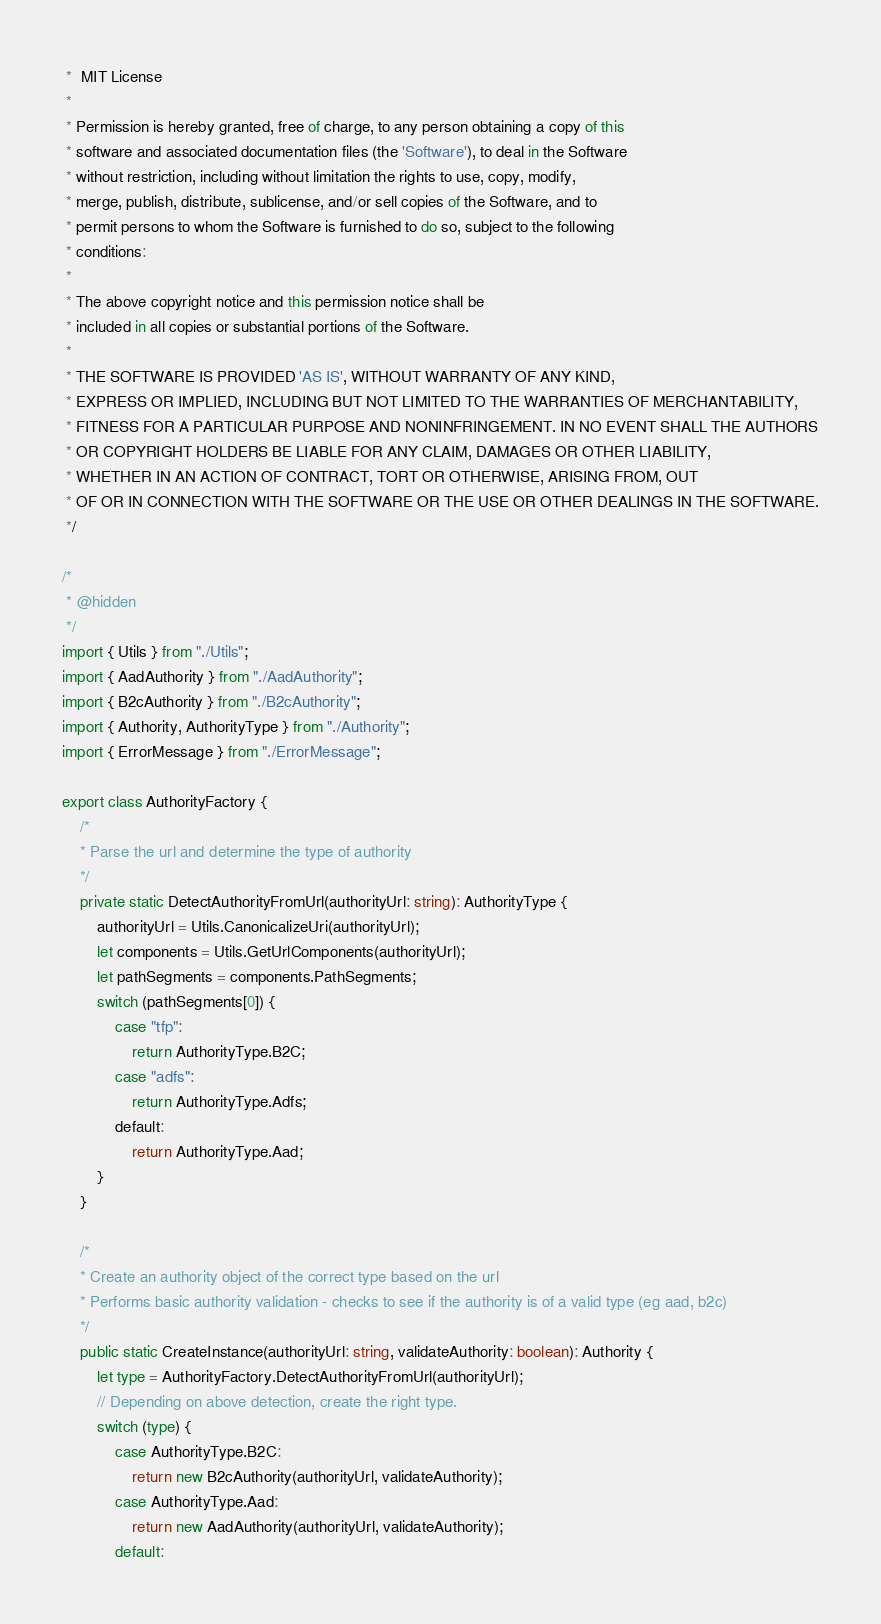<code> <loc_0><loc_0><loc_500><loc_500><_TypeScript_> *  MIT License
 *
 * Permission is hereby granted, free of charge, to any person obtaining a copy of this
 * software and associated documentation files (the 'Software'), to deal in the Software
 * without restriction, including without limitation the rights to use, copy, modify,
 * merge, publish, distribute, sublicense, and/or sell copies of the Software, and to
 * permit persons to whom the Software is furnished to do so, subject to the following
 * conditions:
 *
 * The above copyright notice and this permission notice shall be
 * included in all copies or substantial portions of the Software.
 *
 * THE SOFTWARE IS PROVIDED 'AS IS', WITHOUT WARRANTY OF ANY KIND,
 * EXPRESS OR IMPLIED, INCLUDING BUT NOT LIMITED TO THE WARRANTIES OF MERCHANTABILITY,
 * FITNESS FOR A PARTICULAR PURPOSE AND NONINFRINGEMENT. IN NO EVENT SHALL THE AUTHORS
 * OR COPYRIGHT HOLDERS BE LIABLE FOR ANY CLAIM, DAMAGES OR OTHER LIABILITY,
 * WHETHER IN AN ACTION OF CONTRACT, TORT OR OTHERWISE, ARISING FROM, OUT
 * OF OR IN CONNECTION WITH THE SOFTWARE OR THE USE OR OTHER DEALINGS IN THE SOFTWARE.
 */

/*
 * @hidden
 */
import { Utils } from "./Utils";
import { AadAuthority } from "./AadAuthority";
import { B2cAuthority } from "./B2cAuthority";
import { Authority, AuthorityType } from "./Authority";
import { ErrorMessage } from "./ErrorMessage";

export class AuthorityFactory {
    /*
    * Parse the url and determine the type of authority
    */
    private static DetectAuthorityFromUrl(authorityUrl: string): AuthorityType {
        authorityUrl = Utils.CanonicalizeUri(authorityUrl);
        let components = Utils.GetUrlComponents(authorityUrl);
        let pathSegments = components.PathSegments;
        switch (pathSegments[0]) {
            case "tfp":
                return AuthorityType.B2C;
            case "adfs":
                return AuthorityType.Adfs;
            default:
                return AuthorityType.Aad;
        }
    }

    /*
    * Create an authority object of the correct type based on the url
    * Performs basic authority validation - checks to see if the authority is of a valid type (eg aad, b2c)
    */
    public static CreateInstance(authorityUrl: string, validateAuthority: boolean): Authority {
        let type = AuthorityFactory.DetectAuthorityFromUrl(authorityUrl);
        // Depending on above detection, create the right type.
        switch (type) {
            case AuthorityType.B2C:
                return new B2cAuthority(authorityUrl, validateAuthority);
            case AuthorityType.Aad:
                return new AadAuthority(authorityUrl, validateAuthority);
            default:</code> 